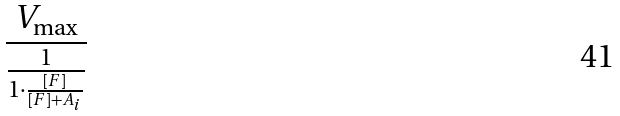<formula> <loc_0><loc_0><loc_500><loc_500>\frac { V _ { \max } } { \frac { 1 } { 1 \cdot \frac { [ F ] } { [ F ] + A _ { i } } } }</formula> 